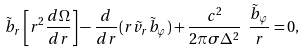<formula> <loc_0><loc_0><loc_500><loc_500>\tilde { b } _ { r } \left [ r ^ { 2 } \frac { d \Omega } { d r } \right ] - \frac { d } { d r } ( r \tilde { v } _ { r } \tilde { b } _ { \varphi } ) + \frac { c ^ { 2 } } { 2 \pi \sigma \Delta ^ { 2 } } \ \frac { \tilde { b } _ { \varphi } } { r } = 0 ,</formula> 